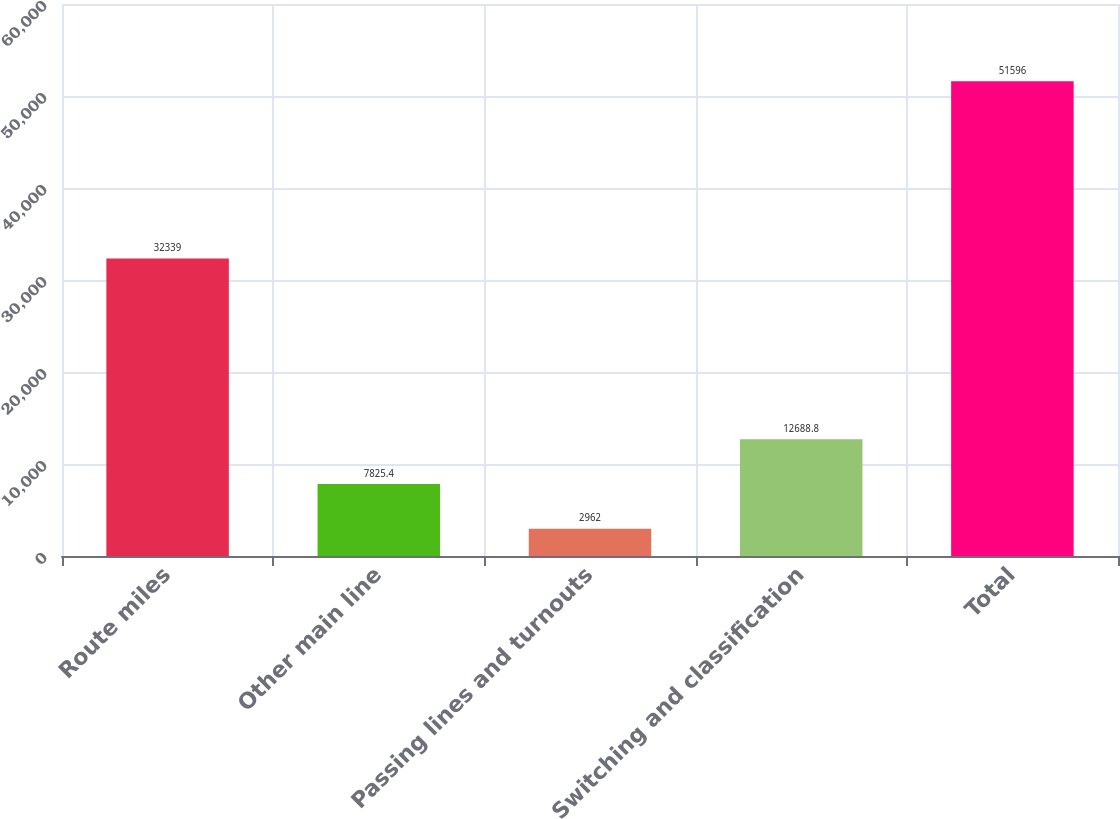Convert chart. <chart><loc_0><loc_0><loc_500><loc_500><bar_chart><fcel>Route miles<fcel>Other main line<fcel>Passing lines and turnouts<fcel>Switching and classification<fcel>Total<nl><fcel>32339<fcel>7825.4<fcel>2962<fcel>12688.8<fcel>51596<nl></chart> 